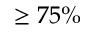Convert formula to latex. <formula><loc_0><loc_0><loc_500><loc_500>\geq 7 5 \%</formula> 